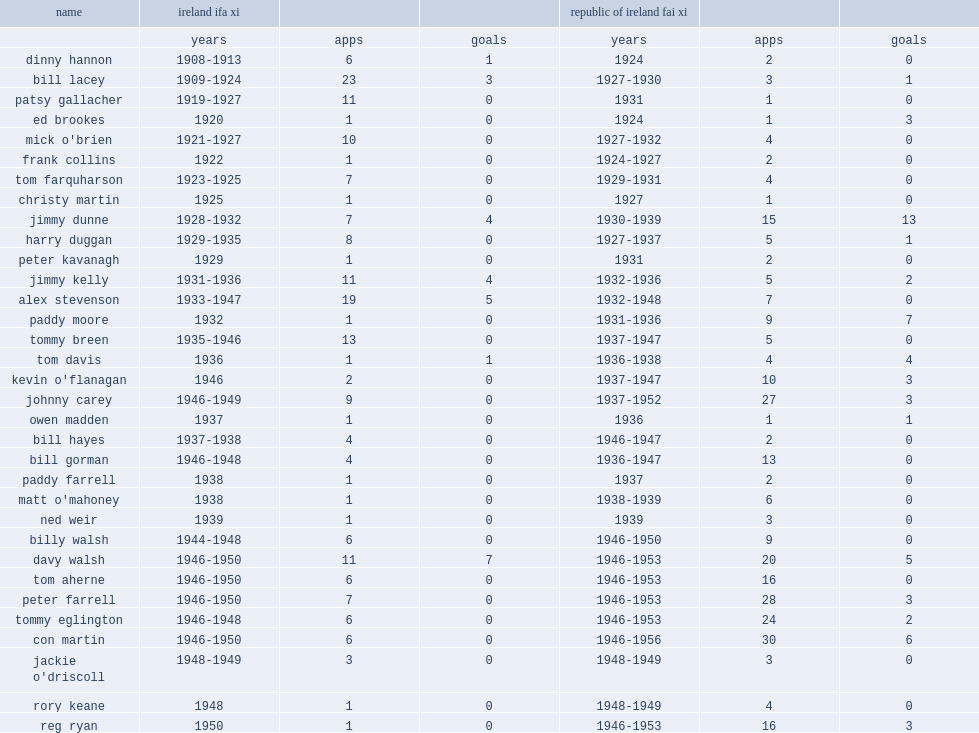What was the number of apps made by eglington for the fai xi ? 24.0. 